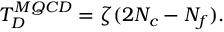Convert formula to latex. <formula><loc_0><loc_0><loc_500><loc_500>T _ { D } ^ { M Q C D } = \zeta ( 2 N _ { c } - N _ { f } ) .</formula> 